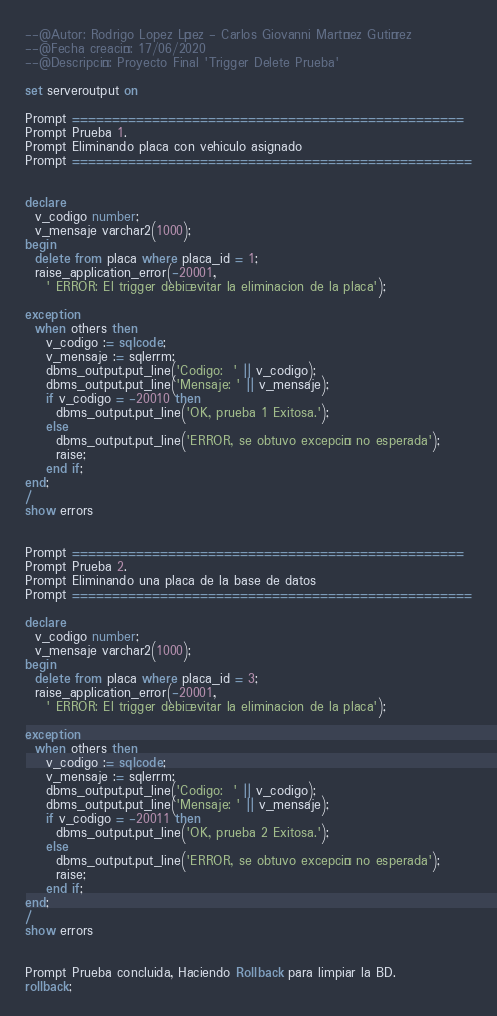Convert code to text. <code><loc_0><loc_0><loc_500><loc_500><_SQL_>--@Autor: Rodrigo Lopez López - Carlos Giovanni Martínez Gutiérrez
--@Fecha creación: 17/06/2020
--@Descripción: Proyecto Final 'Trigger Delete Prueba'

set serveroutput on

Prompt =================================================
Prompt Prueba 1.
Prompt Eliminando placa con vehiculo asignado
Prompt ==================================================


declare
  v_codigo number;
  v_mensaje varchar2(1000);
begin
  delete from placa where placa_id = 1;
  raise_application_error(-20001,
    ' ERROR: El trigger debió evitar la eliminacion de la placa');

exception 
  when others then
    v_codigo := sqlcode;
    v_mensaje := sqlerrm;
    dbms_output.put_line('Codigo:  ' || v_codigo);
    dbms_output.put_line('Mensaje: ' || v_mensaje);
    if v_codigo = -20010 then
      dbms_output.put_line('OK, prueba 1 Exitosa.');
    else
      dbms_output.put_line('ERROR, se obtuvo excepción no esperada');
      raise;
    end if;
end;
/
show errors


Prompt =================================================
Prompt Prueba 2.
Prompt Eliminando una placa de la base de datos
Prompt ==================================================

declare
  v_codigo number;
  v_mensaje varchar2(1000);
begin
  delete from placa where placa_id = 3;
  raise_application_error(-20001,
    ' ERROR: El trigger debió evitar la eliminacion de la placa');

exception 
  when others then
    v_codigo := sqlcode;
    v_mensaje := sqlerrm;
    dbms_output.put_line('Codigo:  ' || v_codigo);
    dbms_output.put_line('Mensaje: ' || v_mensaje);
    if v_codigo = -20011 then
      dbms_output.put_line('OK, prueba 2 Exitosa.');
    else
      dbms_output.put_line('ERROR, se obtuvo excepción no esperada');
      raise;
    end if;
end;
/
show errors


Prompt Prueba concluida, Haciendo Rollback para limpiar la BD.
rollback;</code> 